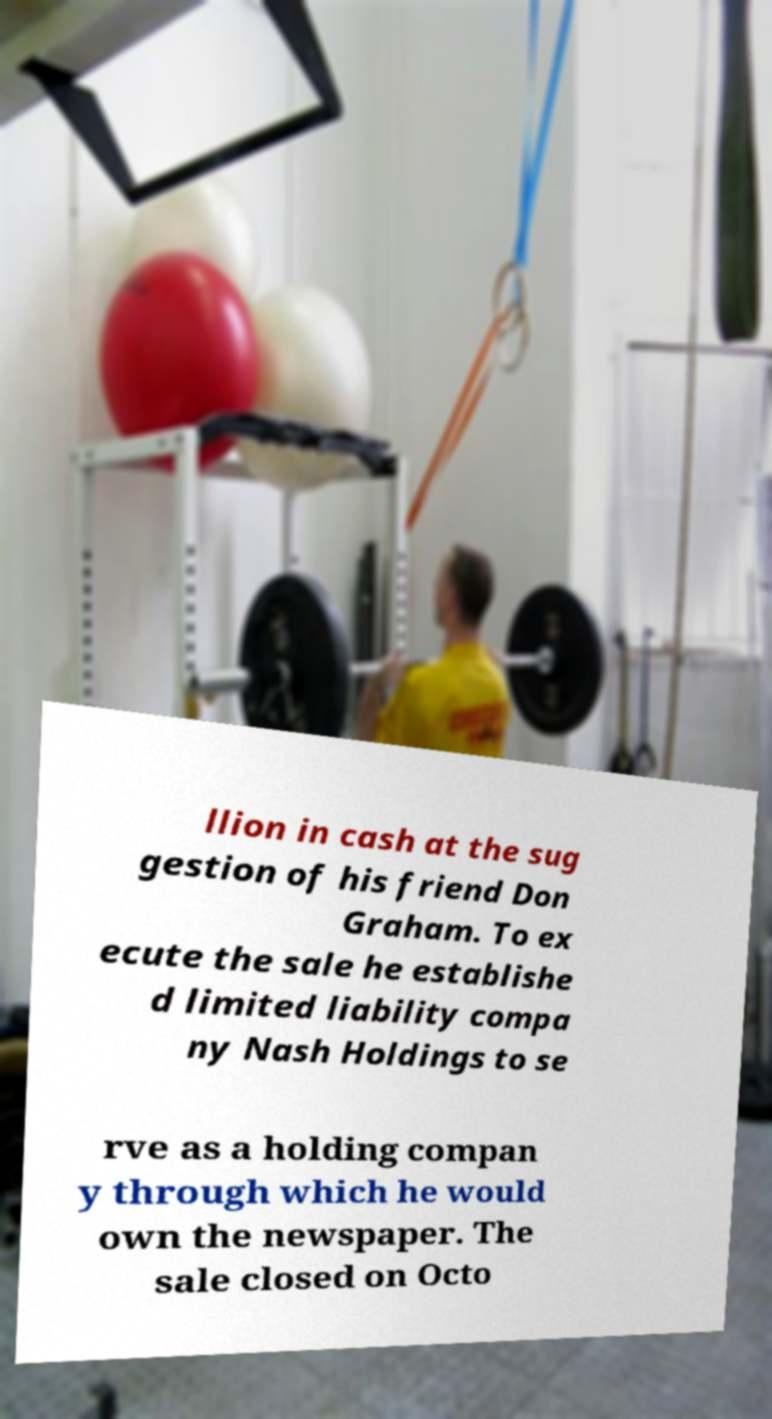For documentation purposes, I need the text within this image transcribed. Could you provide that? llion in cash at the sug gestion of his friend Don Graham. To ex ecute the sale he establishe d limited liability compa ny Nash Holdings to se rve as a holding compan y through which he would own the newspaper. The sale closed on Octo 